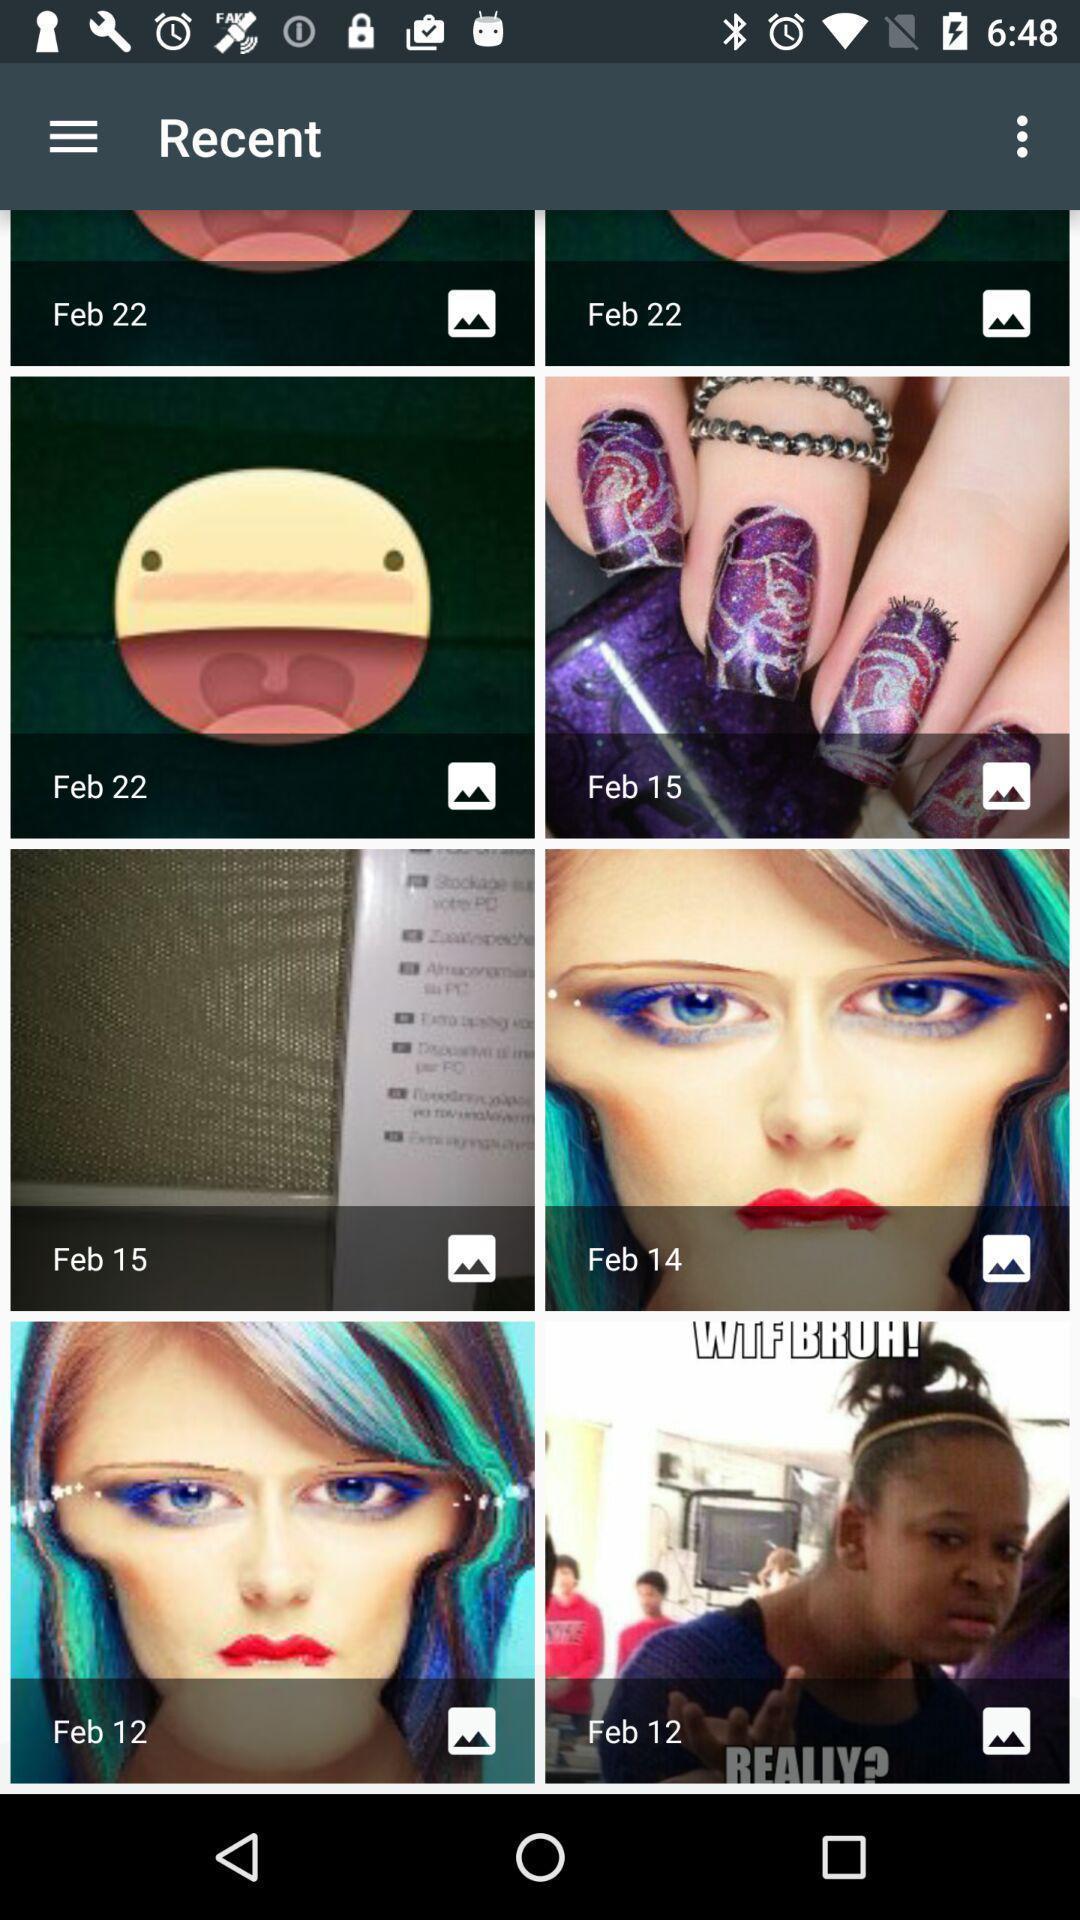Tell me what you see in this picture. Screen shows recent images. 